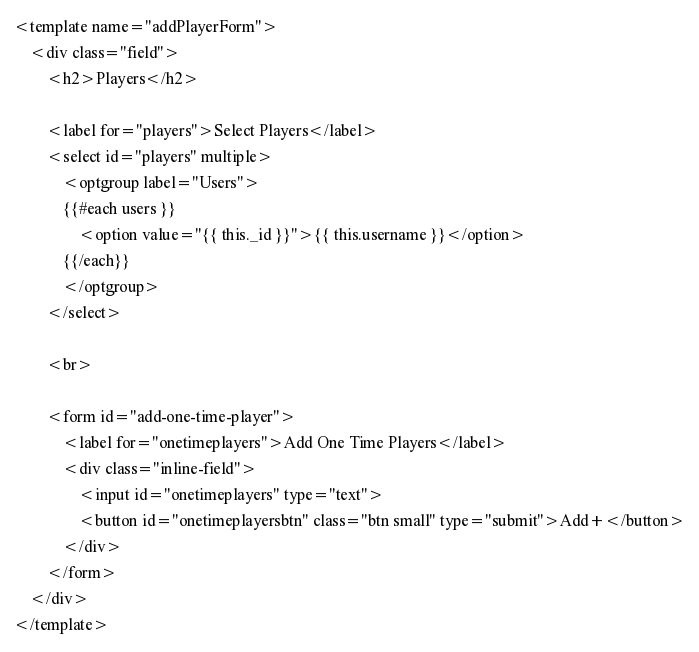Convert code to text. <code><loc_0><loc_0><loc_500><loc_500><_HTML_><template name="addPlayerForm">
	<div class="field">
		<h2>Players</h2>

		<label for="players">Select Players</label>
		<select id="players" multiple>
			<optgroup label="Users">
			{{#each users }}
				<option value="{{ this._id }}">{{ this.username }}</option>
			{{/each}}
			</optgroup>
		</select>

		<br>

		<form id="add-one-time-player">
			<label for="onetimeplayers">Add One Time Players</label>
			<div class="inline-field">
				<input id="onetimeplayers" type="text">
				<button id="onetimeplayersbtn" class="btn small" type="submit">Add+</button>
			</div>
		</form>
	</div>
</template>
</code> 